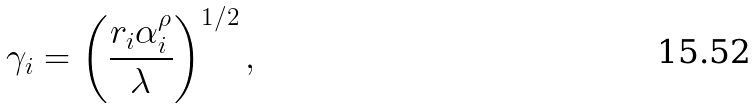<formula> <loc_0><loc_0><loc_500><loc_500>\gamma _ { i } = \left ( \frac { r _ { i } \alpha _ { i } ^ { \rho } } \lambda \right ) ^ { 1 / 2 } ,</formula> 